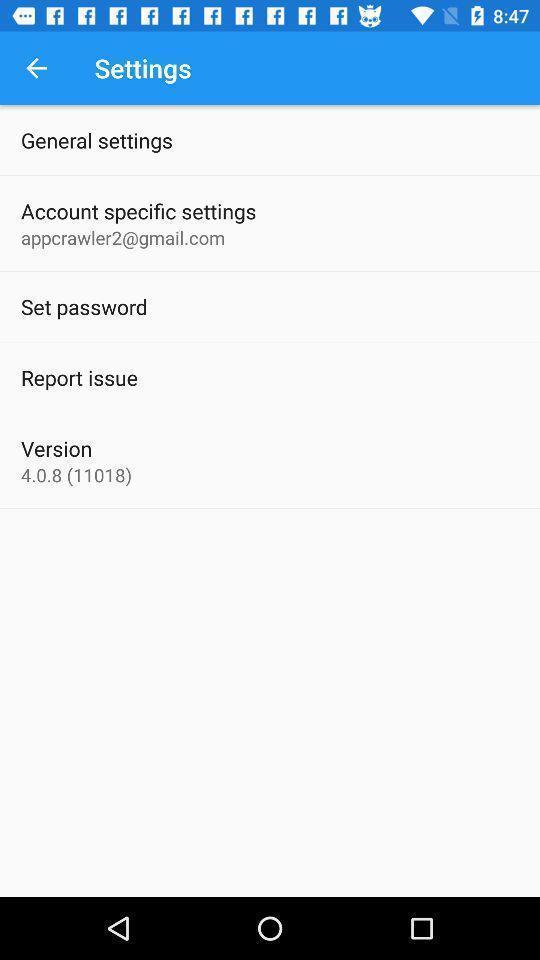What can you discern from this picture? Settings page with various other options. 